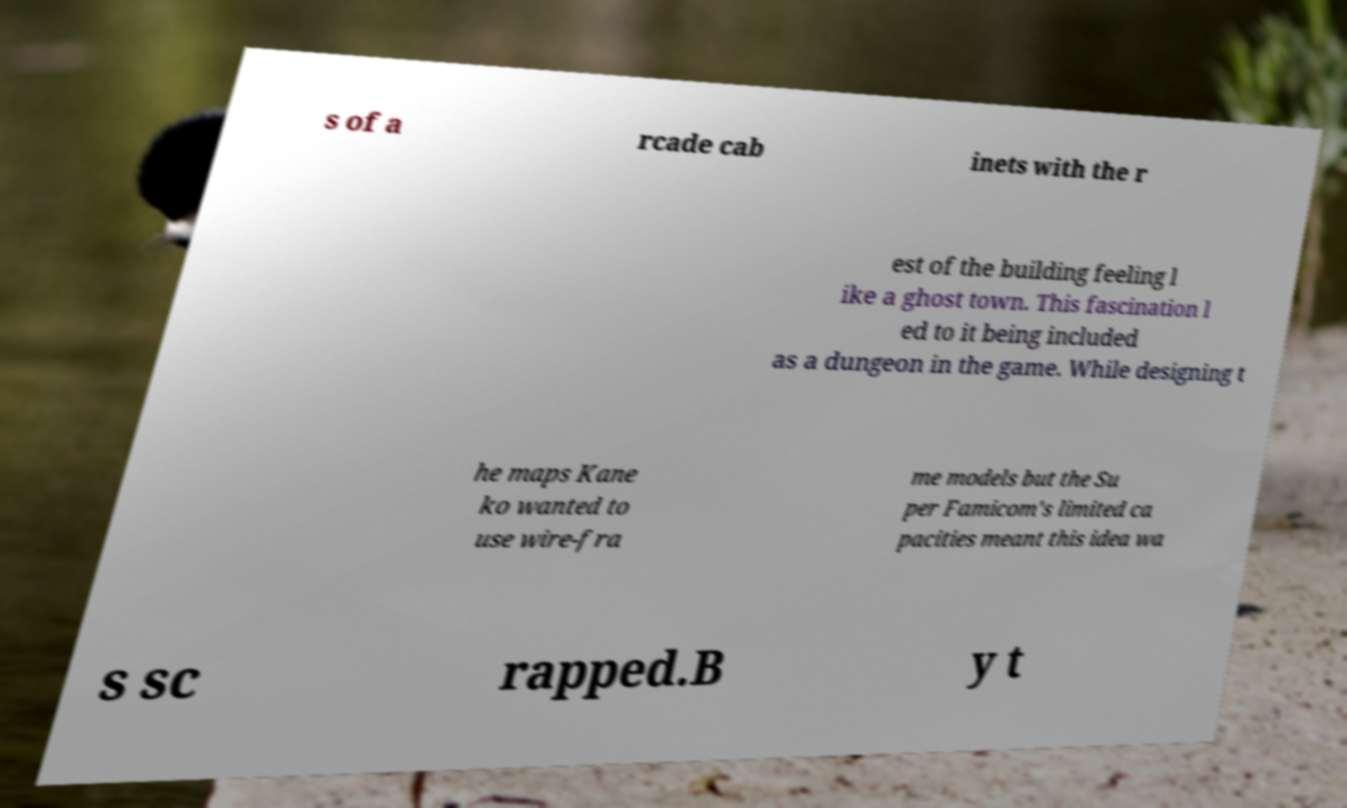For documentation purposes, I need the text within this image transcribed. Could you provide that? s of a rcade cab inets with the r est of the building feeling l ike a ghost town. This fascination l ed to it being included as a dungeon in the game. While designing t he maps Kane ko wanted to use wire-fra me models but the Su per Famicom's limited ca pacities meant this idea wa s sc rapped.B y t 